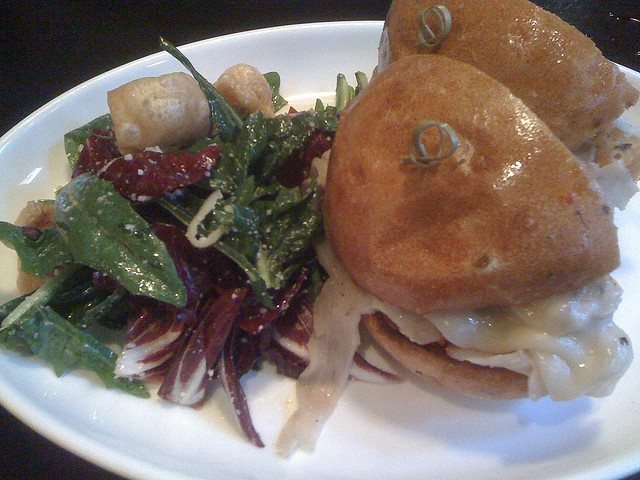Describe the objects in this image and their specific colors. I can see a sandwich in navy, gray, brown, and darkgray tones in this image. 